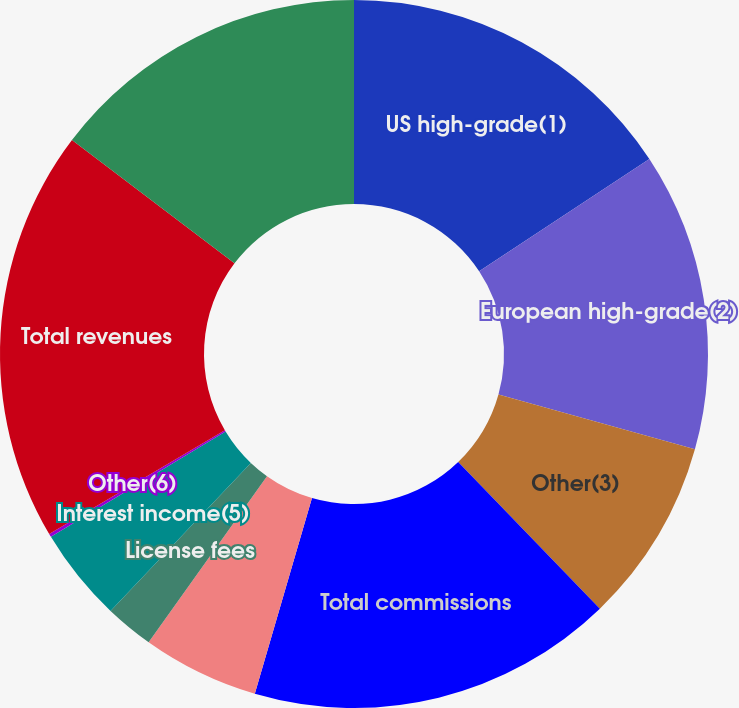<chart> <loc_0><loc_0><loc_500><loc_500><pie_chart><fcel>US high-grade(1)<fcel>European high-grade(2)<fcel>Other(3)<fcel>Total commissions<fcel>Information and user access<fcel>License fees<fcel>Interest income(5)<fcel>Other(6)<fcel>Total revenues<fcel>Employee compensation and<nl><fcel>15.71%<fcel>13.63%<fcel>8.44%<fcel>16.74%<fcel>5.33%<fcel>2.22%<fcel>4.29%<fcel>0.15%<fcel>18.82%<fcel>14.67%<nl></chart> 